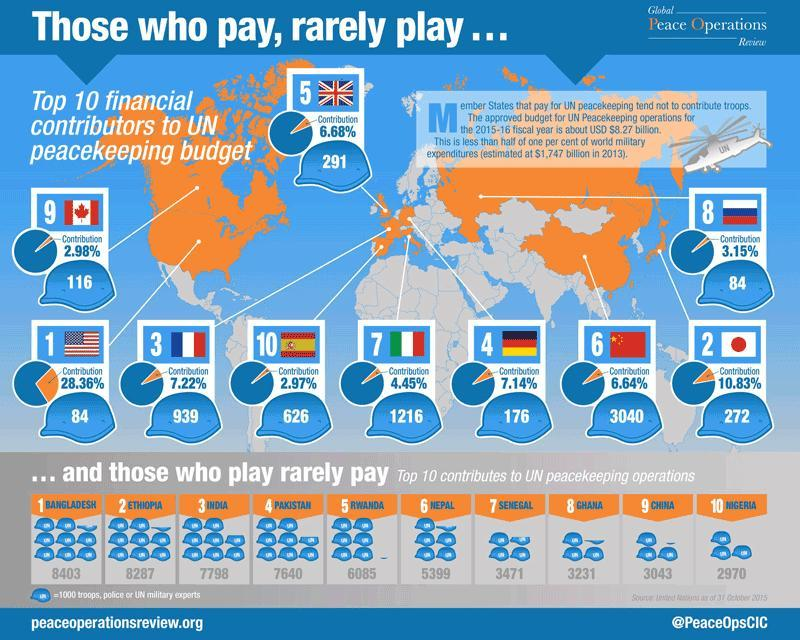What percentage of contribution is made by China in UN peace keeping budget during 2015-16 fiscal year?
Answer the question with a short phrase. 6.64% What is the total number of task forces deployed by India to UN peacekeeping operations during 2015-16 fiscal year? 7798 Which country has contributed the most to UN peacekeeping operations during 2015-16 fiscal year? BANGLADESH What percentage of contribution is made by UK in UN peace keeping budget for 2015-16 fiscal year? 6.68% What percentage of contribution is made by Canada in UN peace keeping budget for 2015-16 fiscal year? 2.98% What is the total number of task forces deployed by Ethiopia to UN peacekeeping operations during 2015-16 fiscal year? 8287 What is the total number of task forces deployed by Nepal to UN peacekeeping operations during 2015-16 fiscal year? 5399 What percentage of contribution is made by USA in UN peace keeping budget for 2015-16 fiscal year? 28.36% 